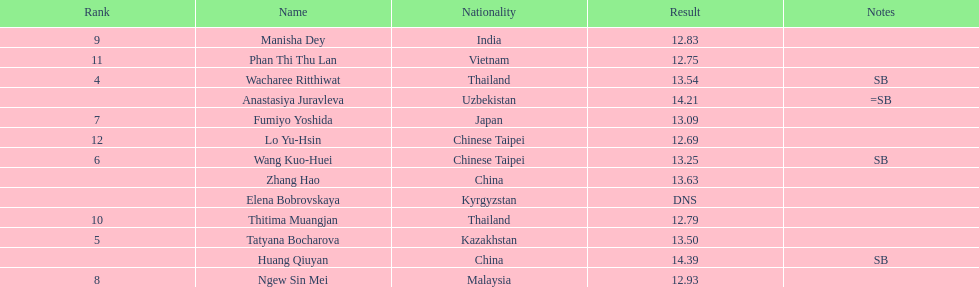Can you parse all the data within this table? {'header': ['Rank', 'Name', 'Nationality', 'Result', 'Notes'], 'rows': [['9', 'Manisha Dey', 'India', '12.83', ''], ['11', 'Phan Thi Thu Lan', 'Vietnam', '12.75', ''], ['4', 'Wacharee Ritthiwat', 'Thailand', '13.54', 'SB'], ['', 'Anastasiya Juravleva', 'Uzbekistan', '14.21', '=SB'], ['7', 'Fumiyo Yoshida', 'Japan', '13.09', ''], ['12', 'Lo Yu-Hsin', 'Chinese Taipei', '12.69', ''], ['6', 'Wang Kuo-Huei', 'Chinese Taipei', '13.25', 'SB'], ['', 'Zhang Hao', 'China', '13.63', ''], ['', 'Elena Bobrovskaya', 'Kyrgyzstan', 'DNS', ''], ['10', 'Thitima Muangjan', 'Thailand', '12.79', ''], ['5', 'Tatyana Bocharova', 'Kazakhstan', '13.50', ''], ['', 'Huang Qiuyan', 'China', '14.39', 'SB'], ['8', 'Ngew Sin Mei', 'Malaysia', '12.93', '']]} Which country came in first? China. 